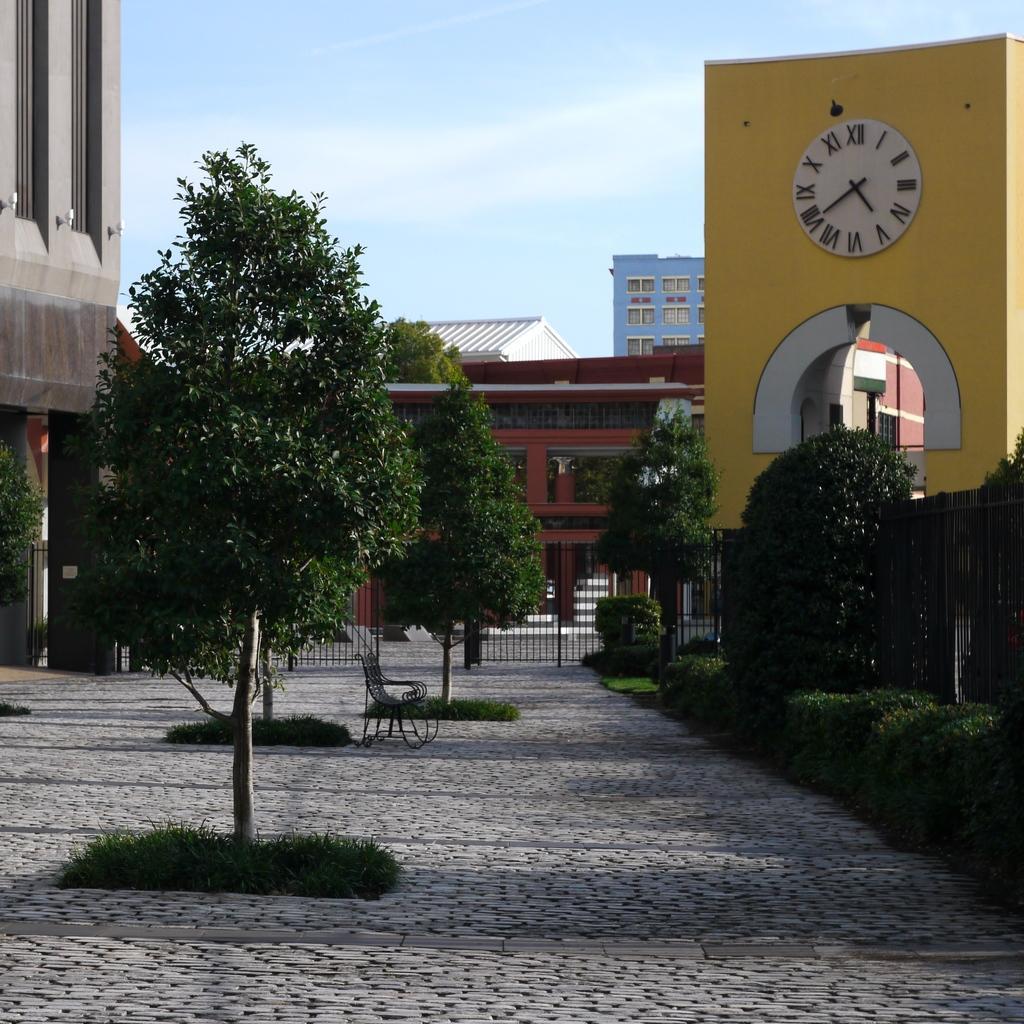Could you give a brief overview of what you see in this image? In this image there is a path, on that path there are trees, in the background there are houses, on the right side there is a clock. 